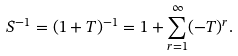Convert formula to latex. <formula><loc_0><loc_0><loc_500><loc_500>S ^ { - 1 } = ( 1 + T ) ^ { - 1 } = 1 + \sum _ { r = 1 } ^ { \infty } ( - T ) ^ { r } .</formula> 